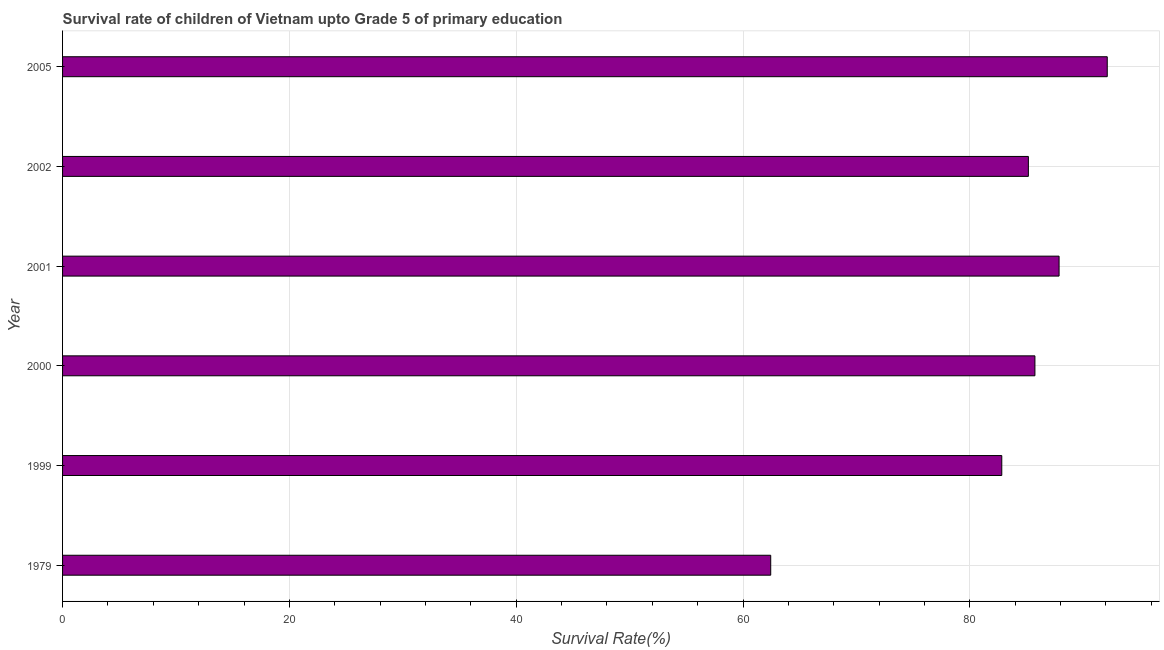What is the title of the graph?
Your answer should be compact. Survival rate of children of Vietnam upto Grade 5 of primary education. What is the label or title of the X-axis?
Offer a very short reply. Survival Rate(%). What is the survival rate in 1979?
Provide a short and direct response. 62.44. Across all years, what is the maximum survival rate?
Your response must be concise. 92.12. Across all years, what is the minimum survival rate?
Offer a terse response. 62.44. In which year was the survival rate minimum?
Offer a very short reply. 1979. What is the sum of the survival rate?
Your response must be concise. 496.17. What is the difference between the survival rate in 2000 and 2001?
Your answer should be very brief. -2.13. What is the average survival rate per year?
Give a very brief answer. 82.69. What is the median survival rate?
Your response must be concise. 85.45. In how many years, is the survival rate greater than 72 %?
Your answer should be very brief. 5. Do a majority of the years between 2002 and 2005 (inclusive) have survival rate greater than 8 %?
Provide a short and direct response. Yes. What is the ratio of the survival rate in 1979 to that in 1999?
Ensure brevity in your answer.  0.75. What is the difference between the highest and the second highest survival rate?
Offer a terse response. 4.25. What is the difference between the highest and the lowest survival rate?
Offer a terse response. 29.68. Are all the bars in the graph horizontal?
Ensure brevity in your answer.  Yes. What is the difference between two consecutive major ticks on the X-axis?
Ensure brevity in your answer.  20. Are the values on the major ticks of X-axis written in scientific E-notation?
Ensure brevity in your answer.  No. What is the Survival Rate(%) in 1979?
Keep it short and to the point. 62.44. What is the Survival Rate(%) of 1999?
Keep it short and to the point. 82.82. What is the Survival Rate(%) of 2000?
Provide a succinct answer. 85.74. What is the Survival Rate(%) in 2001?
Provide a succinct answer. 87.87. What is the Survival Rate(%) in 2002?
Provide a succinct answer. 85.17. What is the Survival Rate(%) in 2005?
Your response must be concise. 92.12. What is the difference between the Survival Rate(%) in 1979 and 1999?
Keep it short and to the point. -20.38. What is the difference between the Survival Rate(%) in 1979 and 2000?
Make the answer very short. -23.3. What is the difference between the Survival Rate(%) in 1979 and 2001?
Give a very brief answer. -25.43. What is the difference between the Survival Rate(%) in 1979 and 2002?
Keep it short and to the point. -22.72. What is the difference between the Survival Rate(%) in 1979 and 2005?
Offer a very short reply. -29.68. What is the difference between the Survival Rate(%) in 1999 and 2000?
Your answer should be very brief. -2.92. What is the difference between the Survival Rate(%) in 1999 and 2001?
Give a very brief answer. -5.05. What is the difference between the Survival Rate(%) in 1999 and 2002?
Offer a very short reply. -2.35. What is the difference between the Survival Rate(%) in 1999 and 2005?
Keep it short and to the point. -9.3. What is the difference between the Survival Rate(%) in 2000 and 2001?
Ensure brevity in your answer.  -2.13. What is the difference between the Survival Rate(%) in 2000 and 2002?
Provide a succinct answer. 0.58. What is the difference between the Survival Rate(%) in 2000 and 2005?
Keep it short and to the point. -6.38. What is the difference between the Survival Rate(%) in 2001 and 2002?
Your response must be concise. 2.71. What is the difference between the Survival Rate(%) in 2001 and 2005?
Offer a terse response. -4.25. What is the difference between the Survival Rate(%) in 2002 and 2005?
Offer a terse response. -6.96. What is the ratio of the Survival Rate(%) in 1979 to that in 1999?
Give a very brief answer. 0.75. What is the ratio of the Survival Rate(%) in 1979 to that in 2000?
Your response must be concise. 0.73. What is the ratio of the Survival Rate(%) in 1979 to that in 2001?
Offer a terse response. 0.71. What is the ratio of the Survival Rate(%) in 1979 to that in 2002?
Your response must be concise. 0.73. What is the ratio of the Survival Rate(%) in 1979 to that in 2005?
Provide a short and direct response. 0.68. What is the ratio of the Survival Rate(%) in 1999 to that in 2001?
Offer a very short reply. 0.94. What is the ratio of the Survival Rate(%) in 1999 to that in 2005?
Your answer should be very brief. 0.9. What is the ratio of the Survival Rate(%) in 2000 to that in 2002?
Offer a terse response. 1.01. What is the ratio of the Survival Rate(%) in 2000 to that in 2005?
Offer a terse response. 0.93. What is the ratio of the Survival Rate(%) in 2001 to that in 2002?
Provide a succinct answer. 1.03. What is the ratio of the Survival Rate(%) in 2001 to that in 2005?
Provide a succinct answer. 0.95. What is the ratio of the Survival Rate(%) in 2002 to that in 2005?
Ensure brevity in your answer.  0.92. 